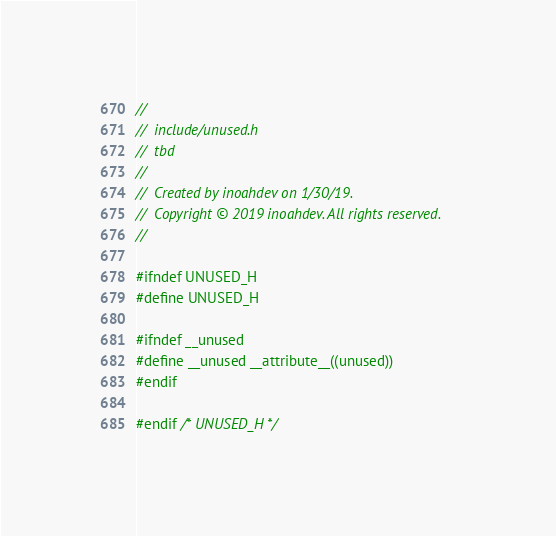<code> <loc_0><loc_0><loc_500><loc_500><_C_>//
//  include/unused.h
//  tbd
//
//  Created by inoahdev on 1/30/19.
//  Copyright © 2019 inoahdev. All rights reserved.
//

#ifndef UNUSED_H
#define UNUSED_H

#ifndef __unused
#define __unused __attribute__((unused))
#endif

#endif /* UNUSED_H */
</code> 